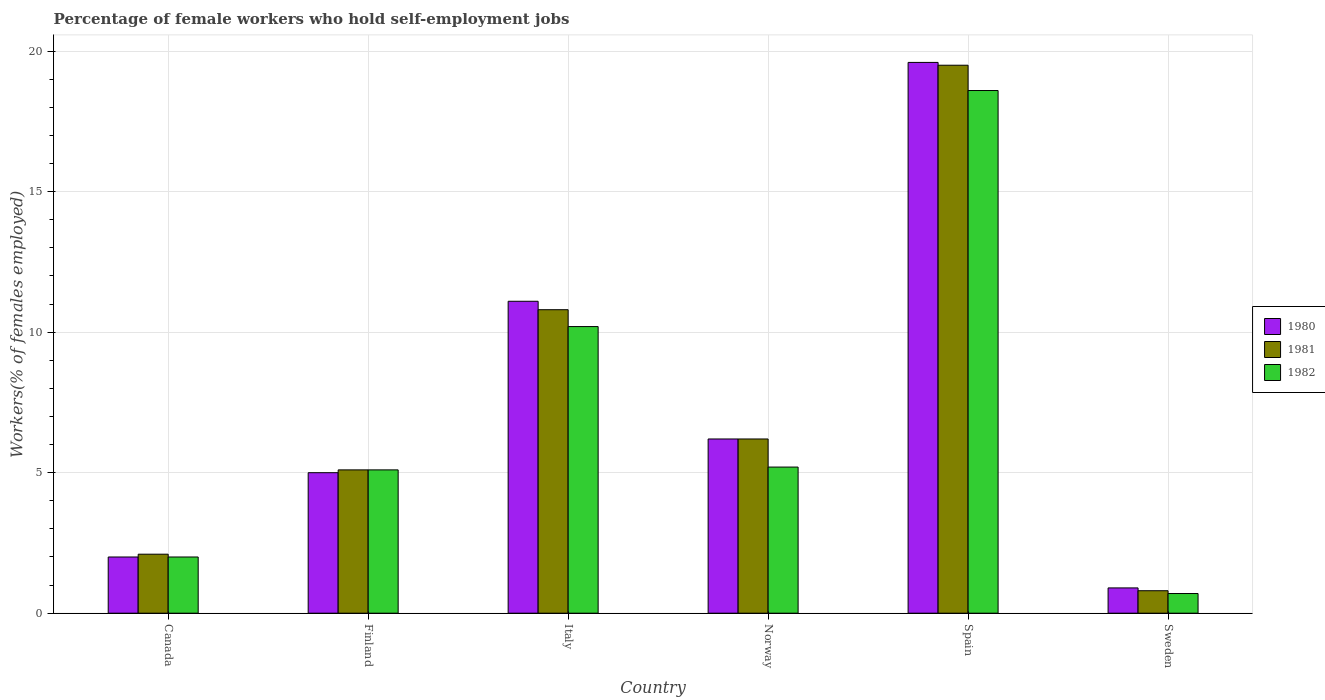How many different coloured bars are there?
Offer a terse response. 3. How many groups of bars are there?
Offer a terse response. 6. Are the number of bars per tick equal to the number of legend labels?
Your answer should be very brief. Yes. How many bars are there on the 1st tick from the left?
Your answer should be very brief. 3. In how many cases, is the number of bars for a given country not equal to the number of legend labels?
Keep it short and to the point. 0. Across all countries, what is the maximum percentage of self-employed female workers in 1982?
Give a very brief answer. 18.6. Across all countries, what is the minimum percentage of self-employed female workers in 1981?
Your answer should be compact. 0.8. In which country was the percentage of self-employed female workers in 1982 maximum?
Provide a short and direct response. Spain. What is the total percentage of self-employed female workers in 1981 in the graph?
Your answer should be very brief. 44.5. What is the difference between the percentage of self-employed female workers in 1980 in Spain and that in Sweden?
Make the answer very short. 18.7. What is the difference between the percentage of self-employed female workers in 1981 in Sweden and the percentage of self-employed female workers in 1980 in Norway?
Offer a terse response. -5.4. What is the average percentage of self-employed female workers in 1982 per country?
Offer a very short reply. 6.97. What is the difference between the percentage of self-employed female workers of/in 1982 and percentage of self-employed female workers of/in 1980 in Italy?
Your response must be concise. -0.9. In how many countries, is the percentage of self-employed female workers in 1981 greater than 4 %?
Offer a terse response. 4. What is the ratio of the percentage of self-employed female workers in 1980 in Canada to that in Italy?
Your response must be concise. 0.18. Is the percentage of self-employed female workers in 1982 in Canada less than that in Norway?
Ensure brevity in your answer.  Yes. What is the difference between the highest and the second highest percentage of self-employed female workers in 1980?
Make the answer very short. -8.5. What is the difference between the highest and the lowest percentage of self-employed female workers in 1981?
Provide a short and direct response. 18.7. In how many countries, is the percentage of self-employed female workers in 1980 greater than the average percentage of self-employed female workers in 1980 taken over all countries?
Your answer should be very brief. 2. Is the sum of the percentage of self-employed female workers in 1982 in Canada and Sweden greater than the maximum percentage of self-employed female workers in 1980 across all countries?
Offer a very short reply. No. Is it the case that in every country, the sum of the percentage of self-employed female workers in 1980 and percentage of self-employed female workers in 1982 is greater than the percentage of self-employed female workers in 1981?
Provide a short and direct response. Yes. How many bars are there?
Ensure brevity in your answer.  18. How many countries are there in the graph?
Your answer should be compact. 6. What is the difference between two consecutive major ticks on the Y-axis?
Keep it short and to the point. 5. Are the values on the major ticks of Y-axis written in scientific E-notation?
Offer a terse response. No. Does the graph contain any zero values?
Make the answer very short. No. Does the graph contain grids?
Provide a succinct answer. Yes. How many legend labels are there?
Make the answer very short. 3. How are the legend labels stacked?
Make the answer very short. Vertical. What is the title of the graph?
Your answer should be compact. Percentage of female workers who hold self-employment jobs. Does "2007" appear as one of the legend labels in the graph?
Offer a terse response. No. What is the label or title of the Y-axis?
Give a very brief answer. Workers(% of females employed). What is the Workers(% of females employed) of 1980 in Canada?
Your response must be concise. 2. What is the Workers(% of females employed) in 1981 in Canada?
Offer a very short reply. 2.1. What is the Workers(% of females employed) of 1982 in Canada?
Ensure brevity in your answer.  2. What is the Workers(% of females employed) of 1980 in Finland?
Your response must be concise. 5. What is the Workers(% of females employed) of 1981 in Finland?
Provide a short and direct response. 5.1. What is the Workers(% of females employed) in 1982 in Finland?
Offer a very short reply. 5.1. What is the Workers(% of females employed) of 1980 in Italy?
Your response must be concise. 11.1. What is the Workers(% of females employed) in 1981 in Italy?
Ensure brevity in your answer.  10.8. What is the Workers(% of females employed) of 1982 in Italy?
Give a very brief answer. 10.2. What is the Workers(% of females employed) in 1980 in Norway?
Give a very brief answer. 6.2. What is the Workers(% of females employed) of 1981 in Norway?
Keep it short and to the point. 6.2. What is the Workers(% of females employed) in 1982 in Norway?
Keep it short and to the point. 5.2. What is the Workers(% of females employed) of 1980 in Spain?
Give a very brief answer. 19.6. What is the Workers(% of females employed) in 1982 in Spain?
Offer a very short reply. 18.6. What is the Workers(% of females employed) of 1980 in Sweden?
Offer a terse response. 0.9. What is the Workers(% of females employed) of 1981 in Sweden?
Provide a short and direct response. 0.8. What is the Workers(% of females employed) of 1982 in Sweden?
Provide a succinct answer. 0.7. Across all countries, what is the maximum Workers(% of females employed) of 1980?
Give a very brief answer. 19.6. Across all countries, what is the maximum Workers(% of females employed) of 1981?
Offer a terse response. 19.5. Across all countries, what is the maximum Workers(% of females employed) of 1982?
Your response must be concise. 18.6. Across all countries, what is the minimum Workers(% of females employed) of 1980?
Make the answer very short. 0.9. Across all countries, what is the minimum Workers(% of females employed) in 1981?
Your answer should be compact. 0.8. Across all countries, what is the minimum Workers(% of females employed) of 1982?
Your response must be concise. 0.7. What is the total Workers(% of females employed) of 1980 in the graph?
Keep it short and to the point. 44.8. What is the total Workers(% of females employed) of 1981 in the graph?
Your answer should be very brief. 44.5. What is the total Workers(% of females employed) of 1982 in the graph?
Offer a very short reply. 41.8. What is the difference between the Workers(% of females employed) in 1981 in Canada and that in Finland?
Make the answer very short. -3. What is the difference between the Workers(% of females employed) in 1982 in Canada and that in Finland?
Offer a terse response. -3.1. What is the difference between the Workers(% of females employed) of 1981 in Canada and that in Italy?
Offer a very short reply. -8.7. What is the difference between the Workers(% of females employed) in 1982 in Canada and that in Italy?
Provide a short and direct response. -8.2. What is the difference between the Workers(% of females employed) in 1982 in Canada and that in Norway?
Keep it short and to the point. -3.2. What is the difference between the Workers(% of females employed) in 1980 in Canada and that in Spain?
Make the answer very short. -17.6. What is the difference between the Workers(% of females employed) in 1981 in Canada and that in Spain?
Keep it short and to the point. -17.4. What is the difference between the Workers(% of females employed) in 1982 in Canada and that in Spain?
Your answer should be very brief. -16.6. What is the difference between the Workers(% of females employed) in 1980 in Finland and that in Italy?
Ensure brevity in your answer.  -6.1. What is the difference between the Workers(% of females employed) in 1982 in Finland and that in Italy?
Ensure brevity in your answer.  -5.1. What is the difference between the Workers(% of females employed) in 1980 in Finland and that in Norway?
Provide a succinct answer. -1.2. What is the difference between the Workers(% of females employed) in 1981 in Finland and that in Norway?
Give a very brief answer. -1.1. What is the difference between the Workers(% of females employed) in 1980 in Finland and that in Spain?
Your answer should be very brief. -14.6. What is the difference between the Workers(% of females employed) in 1981 in Finland and that in Spain?
Offer a terse response. -14.4. What is the difference between the Workers(% of females employed) of 1981 in Finland and that in Sweden?
Ensure brevity in your answer.  4.3. What is the difference between the Workers(% of females employed) in 1981 in Italy and that in Norway?
Your answer should be very brief. 4.6. What is the difference between the Workers(% of females employed) in 1982 in Italy and that in Norway?
Your answer should be compact. 5. What is the difference between the Workers(% of females employed) in 1982 in Italy and that in Spain?
Your answer should be very brief. -8.4. What is the difference between the Workers(% of females employed) of 1982 in Italy and that in Sweden?
Provide a succinct answer. 9.5. What is the difference between the Workers(% of females employed) of 1980 in Norway and that in Spain?
Give a very brief answer. -13.4. What is the difference between the Workers(% of females employed) in 1981 in Norway and that in Spain?
Your answer should be very brief. -13.3. What is the difference between the Workers(% of females employed) in 1982 in Norway and that in Spain?
Offer a very short reply. -13.4. What is the difference between the Workers(% of females employed) of 1980 in Norway and that in Sweden?
Make the answer very short. 5.3. What is the difference between the Workers(% of females employed) in 1981 in Norway and that in Sweden?
Ensure brevity in your answer.  5.4. What is the difference between the Workers(% of females employed) in 1982 in Norway and that in Sweden?
Offer a very short reply. 4.5. What is the difference between the Workers(% of females employed) of 1981 in Spain and that in Sweden?
Keep it short and to the point. 18.7. What is the difference between the Workers(% of females employed) in 1980 in Canada and the Workers(% of females employed) in 1981 in Finland?
Provide a short and direct response. -3.1. What is the difference between the Workers(% of females employed) in 1980 in Canada and the Workers(% of females employed) in 1982 in Finland?
Keep it short and to the point. -3.1. What is the difference between the Workers(% of females employed) in 1980 in Canada and the Workers(% of females employed) in 1981 in Italy?
Your response must be concise. -8.8. What is the difference between the Workers(% of females employed) in 1980 in Canada and the Workers(% of females employed) in 1982 in Norway?
Keep it short and to the point. -3.2. What is the difference between the Workers(% of females employed) of 1980 in Canada and the Workers(% of females employed) of 1981 in Spain?
Your answer should be very brief. -17.5. What is the difference between the Workers(% of females employed) of 1980 in Canada and the Workers(% of females employed) of 1982 in Spain?
Provide a succinct answer. -16.6. What is the difference between the Workers(% of females employed) of 1981 in Canada and the Workers(% of females employed) of 1982 in Spain?
Provide a succinct answer. -16.5. What is the difference between the Workers(% of females employed) of 1980 in Canada and the Workers(% of females employed) of 1981 in Sweden?
Your answer should be very brief. 1.2. What is the difference between the Workers(% of females employed) in 1980 in Canada and the Workers(% of females employed) in 1982 in Sweden?
Your answer should be compact. 1.3. What is the difference between the Workers(% of females employed) of 1980 in Finland and the Workers(% of females employed) of 1982 in Norway?
Your response must be concise. -0.2. What is the difference between the Workers(% of females employed) in 1981 in Finland and the Workers(% of females employed) in 1982 in Norway?
Provide a short and direct response. -0.1. What is the difference between the Workers(% of females employed) in 1981 in Finland and the Workers(% of females employed) in 1982 in Spain?
Keep it short and to the point. -13.5. What is the difference between the Workers(% of females employed) of 1981 in Finland and the Workers(% of females employed) of 1982 in Sweden?
Ensure brevity in your answer.  4.4. What is the difference between the Workers(% of females employed) in 1980 in Italy and the Workers(% of females employed) in 1982 in Norway?
Offer a very short reply. 5.9. What is the difference between the Workers(% of females employed) of 1981 in Italy and the Workers(% of females employed) of 1982 in Spain?
Ensure brevity in your answer.  -7.8. What is the difference between the Workers(% of females employed) in 1980 in Italy and the Workers(% of females employed) in 1981 in Sweden?
Provide a succinct answer. 10.3. What is the difference between the Workers(% of females employed) of 1981 in Italy and the Workers(% of females employed) of 1982 in Sweden?
Provide a short and direct response. 10.1. What is the difference between the Workers(% of females employed) of 1980 in Norway and the Workers(% of females employed) of 1981 in Sweden?
Provide a succinct answer. 5.4. What is the difference between the Workers(% of females employed) of 1980 in Spain and the Workers(% of females employed) of 1982 in Sweden?
Your answer should be very brief. 18.9. What is the difference between the Workers(% of females employed) in 1981 in Spain and the Workers(% of females employed) in 1982 in Sweden?
Provide a short and direct response. 18.8. What is the average Workers(% of females employed) in 1980 per country?
Offer a very short reply. 7.47. What is the average Workers(% of females employed) in 1981 per country?
Your answer should be very brief. 7.42. What is the average Workers(% of females employed) in 1982 per country?
Provide a short and direct response. 6.97. What is the difference between the Workers(% of females employed) in 1980 and Workers(% of females employed) in 1981 in Canada?
Offer a very short reply. -0.1. What is the difference between the Workers(% of females employed) in 1980 and Workers(% of females employed) in 1982 in Canada?
Offer a very short reply. 0. What is the difference between the Workers(% of females employed) of 1981 and Workers(% of females employed) of 1982 in Canada?
Keep it short and to the point. 0.1. What is the difference between the Workers(% of females employed) of 1981 and Workers(% of females employed) of 1982 in Italy?
Provide a short and direct response. 0.6. What is the difference between the Workers(% of females employed) of 1980 and Workers(% of females employed) of 1981 in Norway?
Make the answer very short. 0. What is the difference between the Workers(% of females employed) in 1980 and Workers(% of females employed) in 1982 in Norway?
Offer a terse response. 1. What is the difference between the Workers(% of females employed) in 1981 and Workers(% of females employed) in 1982 in Norway?
Provide a succinct answer. 1. What is the difference between the Workers(% of females employed) of 1980 and Workers(% of females employed) of 1981 in Spain?
Give a very brief answer. 0.1. What is the difference between the Workers(% of females employed) of 1981 and Workers(% of females employed) of 1982 in Spain?
Offer a very short reply. 0.9. What is the difference between the Workers(% of females employed) in 1980 and Workers(% of females employed) in 1981 in Sweden?
Provide a succinct answer. 0.1. What is the difference between the Workers(% of females employed) of 1981 and Workers(% of females employed) of 1982 in Sweden?
Provide a succinct answer. 0.1. What is the ratio of the Workers(% of females employed) of 1980 in Canada to that in Finland?
Your answer should be compact. 0.4. What is the ratio of the Workers(% of females employed) in 1981 in Canada to that in Finland?
Your answer should be very brief. 0.41. What is the ratio of the Workers(% of females employed) of 1982 in Canada to that in Finland?
Ensure brevity in your answer.  0.39. What is the ratio of the Workers(% of females employed) in 1980 in Canada to that in Italy?
Provide a short and direct response. 0.18. What is the ratio of the Workers(% of females employed) in 1981 in Canada to that in Italy?
Provide a short and direct response. 0.19. What is the ratio of the Workers(% of females employed) in 1982 in Canada to that in Italy?
Give a very brief answer. 0.2. What is the ratio of the Workers(% of females employed) of 1980 in Canada to that in Norway?
Provide a succinct answer. 0.32. What is the ratio of the Workers(% of females employed) of 1981 in Canada to that in Norway?
Provide a short and direct response. 0.34. What is the ratio of the Workers(% of females employed) in 1982 in Canada to that in Norway?
Your response must be concise. 0.38. What is the ratio of the Workers(% of females employed) of 1980 in Canada to that in Spain?
Your answer should be compact. 0.1. What is the ratio of the Workers(% of females employed) of 1981 in Canada to that in Spain?
Offer a terse response. 0.11. What is the ratio of the Workers(% of females employed) of 1982 in Canada to that in Spain?
Your response must be concise. 0.11. What is the ratio of the Workers(% of females employed) of 1980 in Canada to that in Sweden?
Offer a terse response. 2.22. What is the ratio of the Workers(% of females employed) of 1981 in Canada to that in Sweden?
Keep it short and to the point. 2.62. What is the ratio of the Workers(% of females employed) in 1982 in Canada to that in Sweden?
Offer a terse response. 2.86. What is the ratio of the Workers(% of females employed) of 1980 in Finland to that in Italy?
Provide a short and direct response. 0.45. What is the ratio of the Workers(% of females employed) of 1981 in Finland to that in Italy?
Make the answer very short. 0.47. What is the ratio of the Workers(% of females employed) of 1980 in Finland to that in Norway?
Offer a terse response. 0.81. What is the ratio of the Workers(% of females employed) of 1981 in Finland to that in Norway?
Keep it short and to the point. 0.82. What is the ratio of the Workers(% of females employed) of 1982 in Finland to that in Norway?
Make the answer very short. 0.98. What is the ratio of the Workers(% of females employed) in 1980 in Finland to that in Spain?
Your response must be concise. 0.26. What is the ratio of the Workers(% of females employed) of 1981 in Finland to that in Spain?
Make the answer very short. 0.26. What is the ratio of the Workers(% of females employed) of 1982 in Finland to that in Spain?
Ensure brevity in your answer.  0.27. What is the ratio of the Workers(% of females employed) of 1980 in Finland to that in Sweden?
Ensure brevity in your answer.  5.56. What is the ratio of the Workers(% of females employed) in 1981 in Finland to that in Sweden?
Provide a short and direct response. 6.38. What is the ratio of the Workers(% of females employed) of 1982 in Finland to that in Sweden?
Make the answer very short. 7.29. What is the ratio of the Workers(% of females employed) of 1980 in Italy to that in Norway?
Ensure brevity in your answer.  1.79. What is the ratio of the Workers(% of females employed) of 1981 in Italy to that in Norway?
Keep it short and to the point. 1.74. What is the ratio of the Workers(% of females employed) in 1982 in Italy to that in Norway?
Give a very brief answer. 1.96. What is the ratio of the Workers(% of females employed) in 1980 in Italy to that in Spain?
Provide a succinct answer. 0.57. What is the ratio of the Workers(% of females employed) of 1981 in Italy to that in Spain?
Give a very brief answer. 0.55. What is the ratio of the Workers(% of females employed) of 1982 in Italy to that in Spain?
Make the answer very short. 0.55. What is the ratio of the Workers(% of females employed) of 1980 in Italy to that in Sweden?
Provide a short and direct response. 12.33. What is the ratio of the Workers(% of females employed) of 1981 in Italy to that in Sweden?
Provide a succinct answer. 13.5. What is the ratio of the Workers(% of females employed) of 1982 in Italy to that in Sweden?
Offer a terse response. 14.57. What is the ratio of the Workers(% of females employed) of 1980 in Norway to that in Spain?
Provide a succinct answer. 0.32. What is the ratio of the Workers(% of females employed) in 1981 in Norway to that in Spain?
Offer a terse response. 0.32. What is the ratio of the Workers(% of females employed) in 1982 in Norway to that in Spain?
Your answer should be compact. 0.28. What is the ratio of the Workers(% of females employed) in 1980 in Norway to that in Sweden?
Make the answer very short. 6.89. What is the ratio of the Workers(% of females employed) in 1981 in Norway to that in Sweden?
Offer a terse response. 7.75. What is the ratio of the Workers(% of females employed) in 1982 in Norway to that in Sweden?
Ensure brevity in your answer.  7.43. What is the ratio of the Workers(% of females employed) of 1980 in Spain to that in Sweden?
Provide a succinct answer. 21.78. What is the ratio of the Workers(% of females employed) in 1981 in Spain to that in Sweden?
Your answer should be compact. 24.38. What is the ratio of the Workers(% of females employed) of 1982 in Spain to that in Sweden?
Give a very brief answer. 26.57. What is the difference between the highest and the second highest Workers(% of females employed) in 1980?
Provide a short and direct response. 8.5. What is the difference between the highest and the second highest Workers(% of females employed) in 1981?
Offer a very short reply. 8.7. What is the difference between the highest and the second highest Workers(% of females employed) in 1982?
Give a very brief answer. 8.4. 